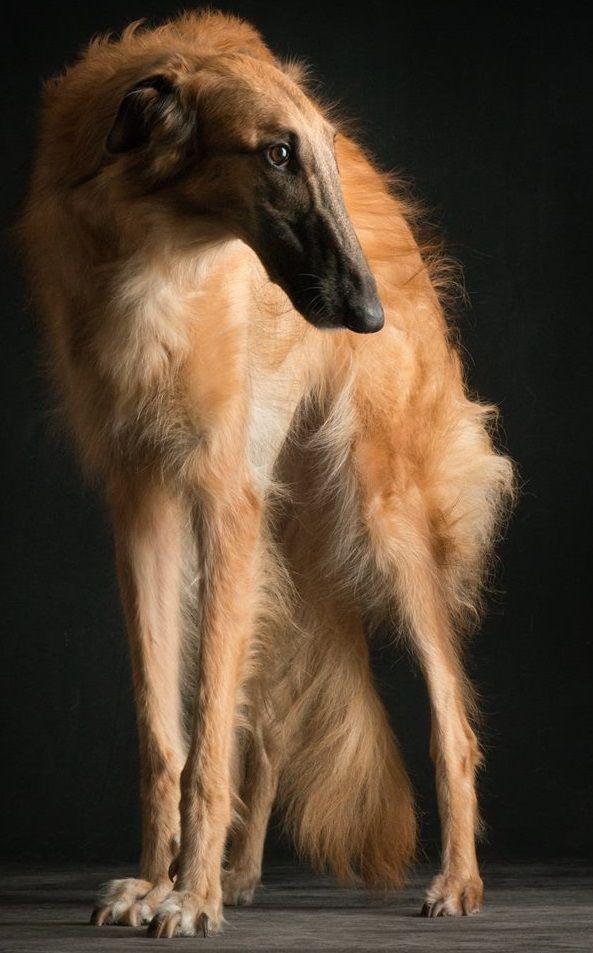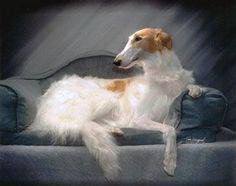The first image is the image on the left, the second image is the image on the right. Examine the images to the left and right. Is the description "The right image shows a hound posed on an upholstered chair, with one front paw propped on the side of the chair." accurate? Answer yes or no. Yes. The first image is the image on the left, the second image is the image on the right. Assess this claim about the two images: "A dog is in a chair.". Correct or not? Answer yes or no. Yes. 